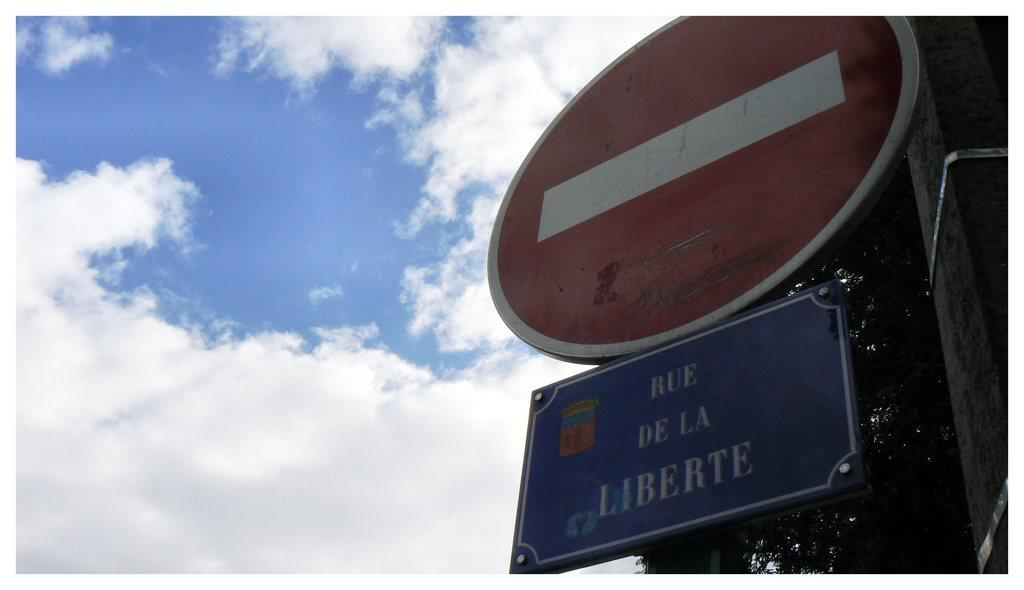<image>
Write a terse but informative summary of the picture. Motorists may not enter Rue de la Liberte. 